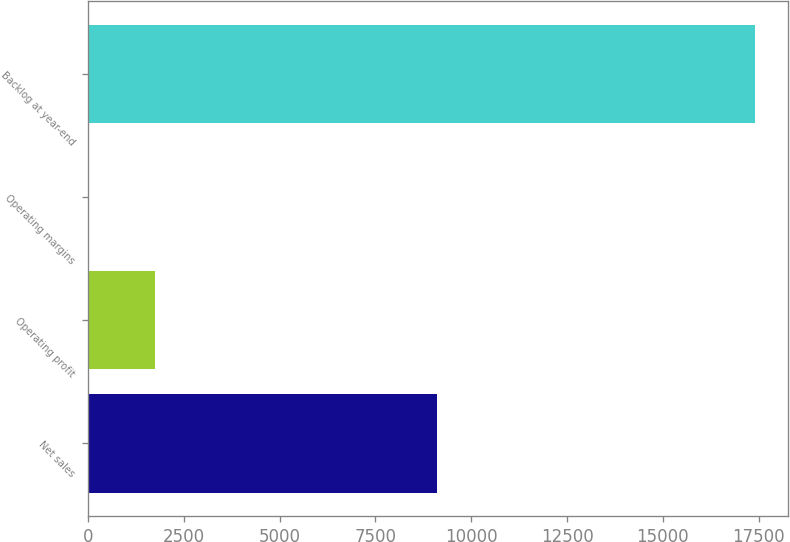Convert chart to OTSL. <chart><loc_0><loc_0><loc_500><loc_500><bar_chart><fcel>Net sales<fcel>Operating profit<fcel>Operating margins<fcel>Backlog at year-end<nl><fcel>9105<fcel>1751.61<fcel>12.9<fcel>17400<nl></chart> 